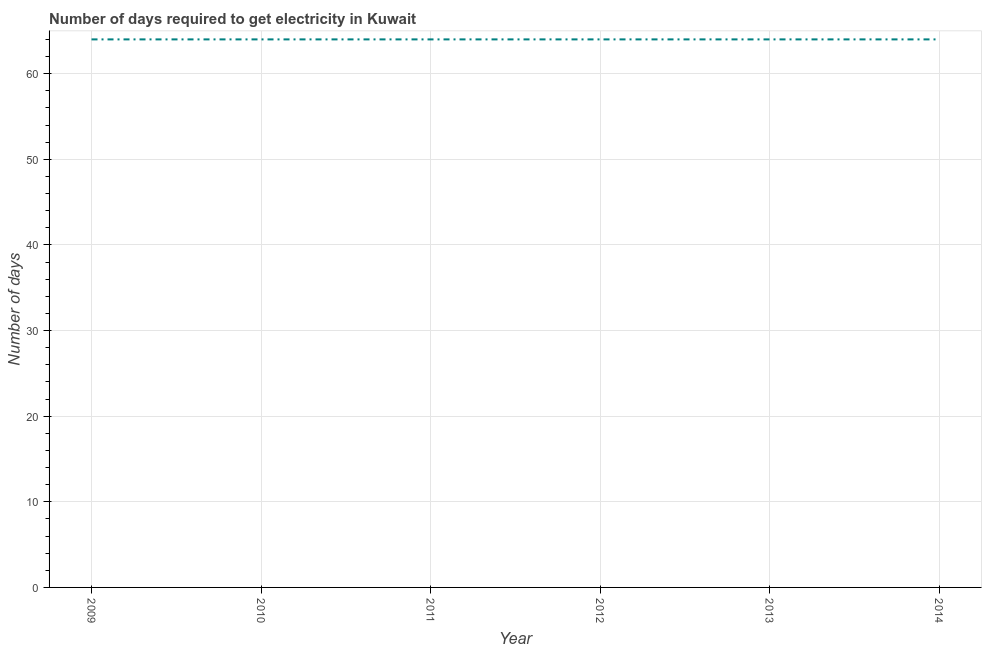What is the time to get electricity in 2012?
Provide a short and direct response. 64. Across all years, what is the maximum time to get electricity?
Provide a succinct answer. 64. Across all years, what is the minimum time to get electricity?
Provide a short and direct response. 64. What is the sum of the time to get electricity?
Your answer should be very brief. 384. What is the median time to get electricity?
Your answer should be very brief. 64. What is the ratio of the time to get electricity in 2010 to that in 2014?
Offer a terse response. 1. Is the time to get electricity in 2010 less than that in 2012?
Your response must be concise. No. Is the sum of the time to get electricity in 2009 and 2011 greater than the maximum time to get electricity across all years?
Keep it short and to the point. Yes. Does the time to get electricity monotonically increase over the years?
Offer a terse response. No. How many lines are there?
Offer a terse response. 1. What is the difference between two consecutive major ticks on the Y-axis?
Offer a very short reply. 10. What is the title of the graph?
Give a very brief answer. Number of days required to get electricity in Kuwait. What is the label or title of the X-axis?
Make the answer very short. Year. What is the label or title of the Y-axis?
Your answer should be very brief. Number of days. What is the Number of days of 2010?
Your response must be concise. 64. What is the Number of days of 2013?
Provide a short and direct response. 64. What is the Number of days in 2014?
Provide a succinct answer. 64. What is the difference between the Number of days in 2009 and 2011?
Keep it short and to the point. 0. What is the difference between the Number of days in 2009 and 2012?
Your response must be concise. 0. What is the difference between the Number of days in 2009 and 2013?
Provide a short and direct response. 0. What is the difference between the Number of days in 2010 and 2011?
Provide a succinct answer. 0. What is the difference between the Number of days in 2010 and 2014?
Give a very brief answer. 0. What is the difference between the Number of days in 2011 and 2014?
Your answer should be compact. 0. What is the difference between the Number of days in 2012 and 2013?
Offer a very short reply. 0. What is the difference between the Number of days in 2013 and 2014?
Your answer should be compact. 0. What is the ratio of the Number of days in 2009 to that in 2010?
Ensure brevity in your answer.  1. What is the ratio of the Number of days in 2009 to that in 2013?
Offer a very short reply. 1. What is the ratio of the Number of days in 2010 to that in 2011?
Give a very brief answer. 1. What is the ratio of the Number of days in 2010 to that in 2012?
Offer a very short reply. 1. What is the ratio of the Number of days in 2010 to that in 2014?
Provide a short and direct response. 1. What is the ratio of the Number of days in 2011 to that in 2012?
Keep it short and to the point. 1. What is the ratio of the Number of days in 2011 to that in 2013?
Ensure brevity in your answer.  1. What is the ratio of the Number of days in 2011 to that in 2014?
Your answer should be very brief. 1. What is the ratio of the Number of days in 2012 to that in 2013?
Make the answer very short. 1. What is the ratio of the Number of days in 2013 to that in 2014?
Your answer should be compact. 1. 